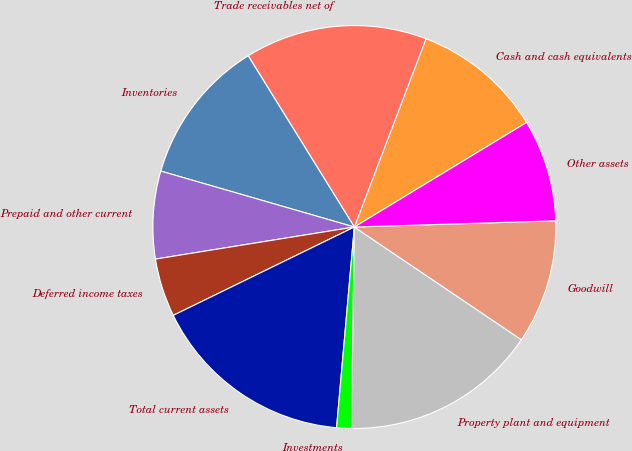<chart> <loc_0><loc_0><loc_500><loc_500><pie_chart><fcel>Cash and cash equivalents<fcel>Trade receivables net of<fcel>Inventories<fcel>Prepaid and other current<fcel>Deferred income taxes<fcel>Total current assets<fcel>Investments<fcel>Property plant and equipment<fcel>Goodwill<fcel>Other assets<nl><fcel>10.53%<fcel>14.62%<fcel>11.69%<fcel>7.02%<fcel>4.68%<fcel>16.37%<fcel>1.18%<fcel>15.78%<fcel>9.94%<fcel>8.19%<nl></chart> 